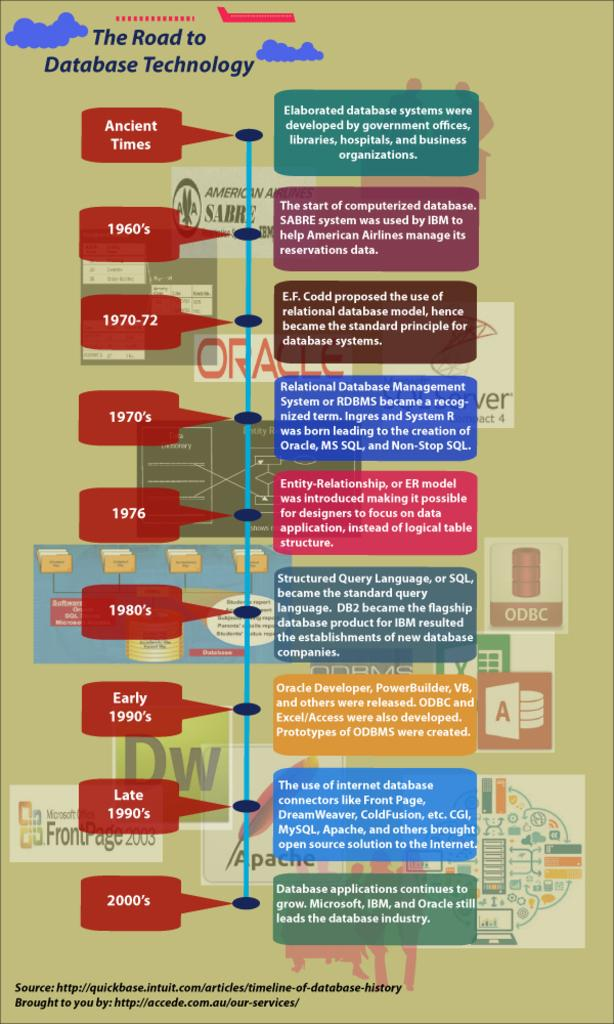<image>
Describe the image concisely. A rectangular green poster with the words "The Road to Database Technology" written on top. 